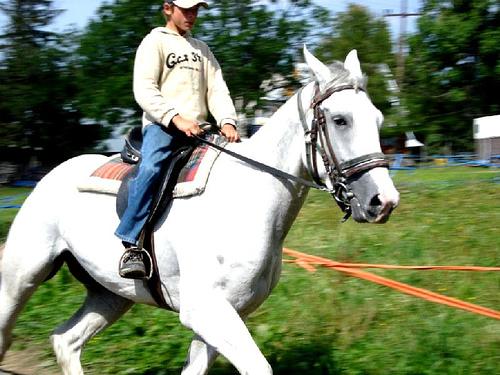How does the rider control the direction of the horse?
Answer briefly. Reins. Are there mountains in the background?
Concise answer only. No. Does the person on the horse look older than 50 years old?
Answer briefly. No. What kind of hat is the person wearing?
Quick response, please. Baseball. 